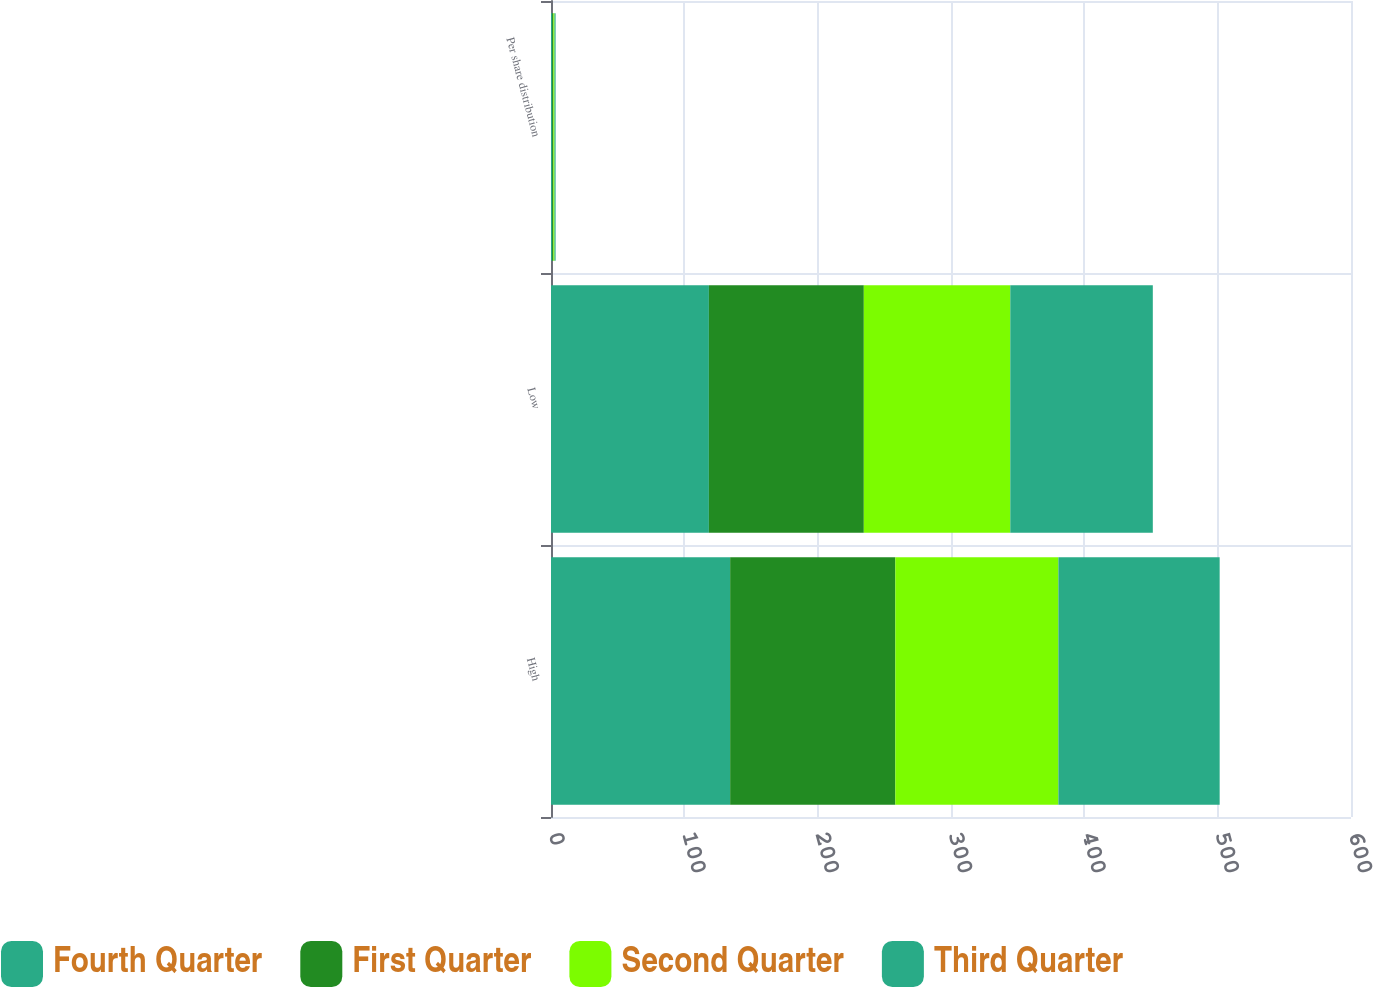<chart> <loc_0><loc_0><loc_500><loc_500><stacked_bar_chart><ecel><fcel>High<fcel>Low<fcel>Per share distribution<nl><fcel>Fourth Quarter<fcel>134.37<fcel>118.42<fcel>0.9<nl><fcel>First Quarter<fcel>123.89<fcel>116.2<fcel>0.86<nl><fcel>Second Quarter<fcel>122.28<fcel>109.85<fcel>0.86<nl><fcel>Third Quarter<fcel>120.96<fcel>106.89<fcel>0.83<nl></chart> 